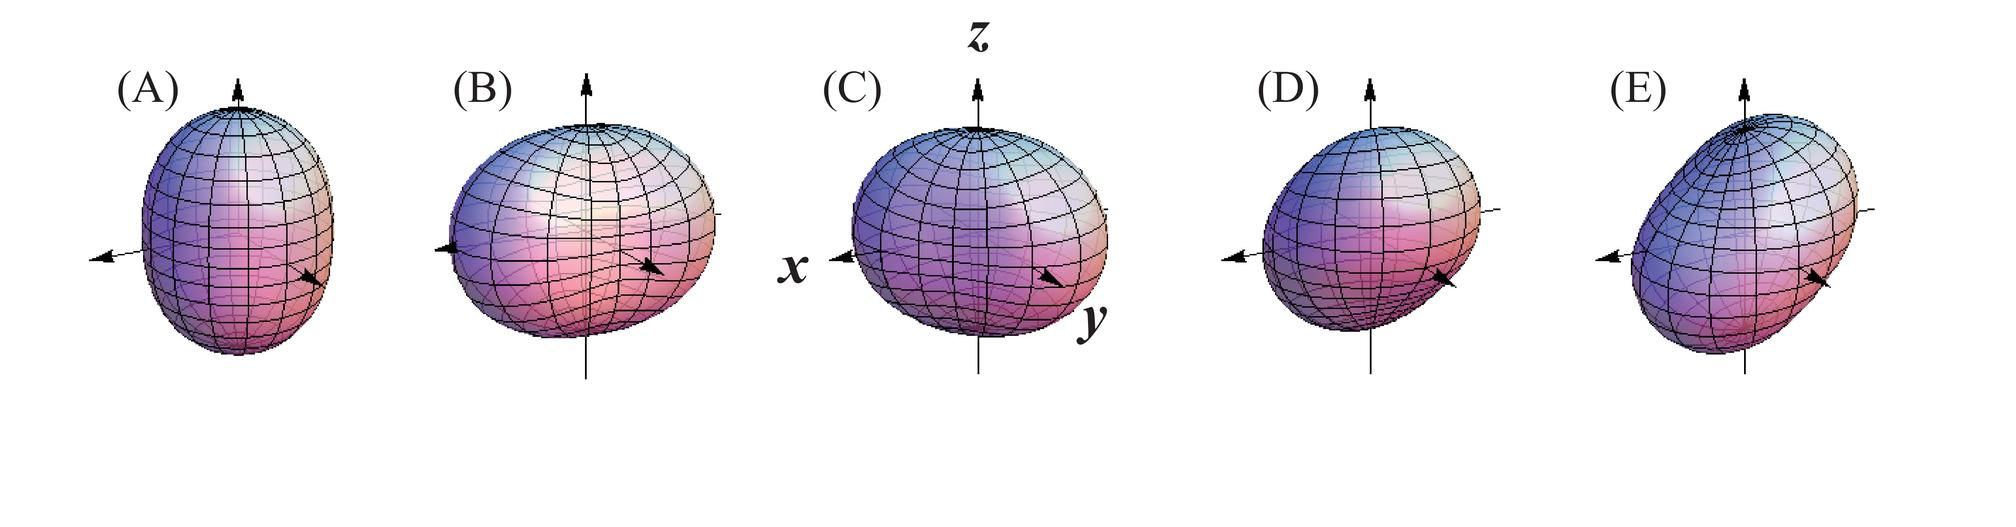What can these figures tell us about the material properties of the object? These figures suggest that the object has elastic properties, meaning it can deform in response to force and then return to its original shape once the force is removed. The difference in deformation patterns across the figures also hints at anisotropy in the material's structure, where the material possesses different properties in different directions, which can affect how it deforms under stress. 